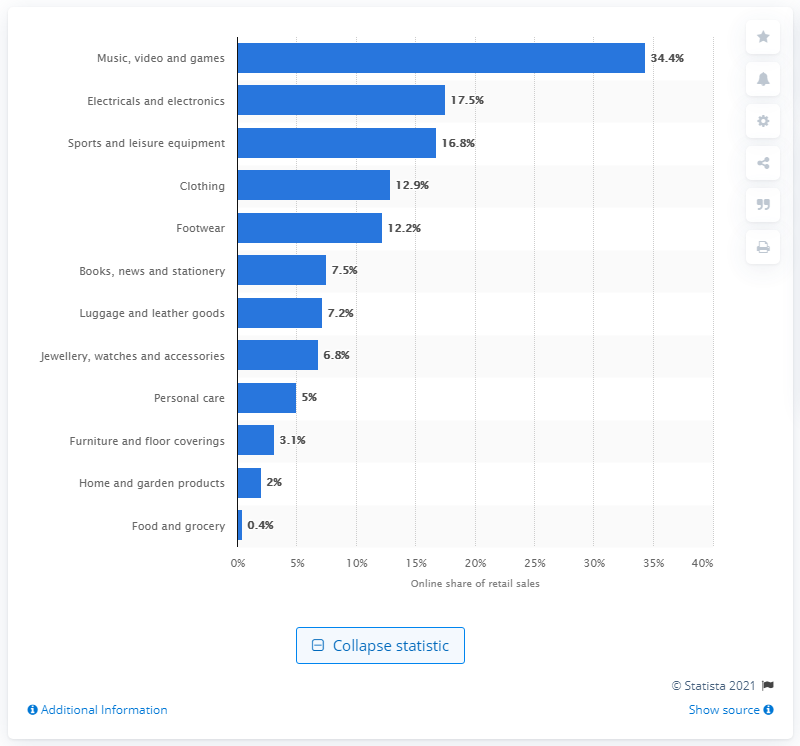Specify some key components in this picture. According to the data, the online share of retail sales of music, video, and games was 34.4%. 